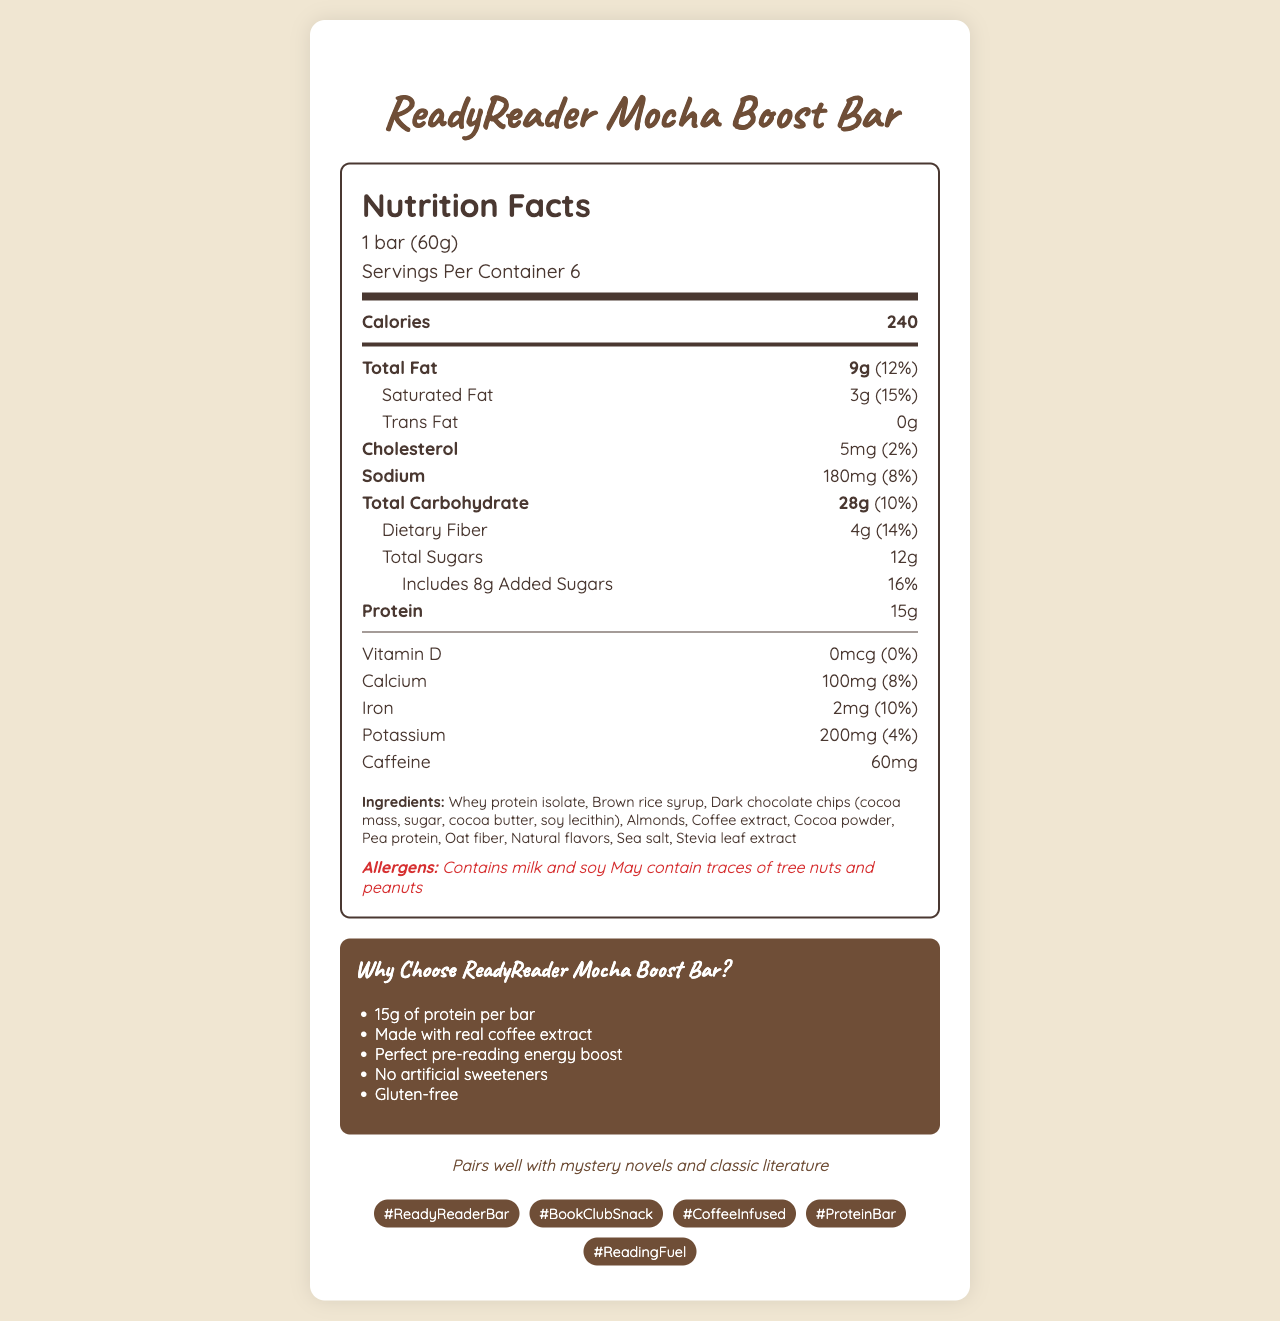what is the serving size of the ReadyReader Mocha Boost Bar? The serving size is explicitly mentioned in the nutrition label section of the document as "1 bar (60g)".
Answer: 1 bar (60g) How many servings are there per container? The document states that there are 6 servings per container.
Answer: 6 How much protein is in one bar? According to the nutrition facts, each bar contains 15 grams of protein.
Answer: 15g What percentage of the daily value of saturated fat does one bar provide? The document lists the daily value percentage for saturated fat as 15%.
Answer: 15% How many grams of dietary fiber are in one bar? The nutrition facts show that there are 4 grams of dietary fiber in one bar.
Answer: 4g Which ingredient lists "soy lecithin" as a component? The listed ingredients show dark chocolate chips containing cocoa mass, sugar, cocoa butter, and soy lecithin.
Answer: Dark chocolate chips Which vitamin or mineral has the highest daily value percentage? A. Calcium B. Iron C. Potassium Iron has a daily value percentage of 10%, which is higher compared to calcium (8%) and potassium (4%).
Answer: B. Iron What is the amount of added sugars in one bar? A. 4g B. 6g C. 8g D. 10g The nutrition facts show that the bar includes 8 grams of added sugars.
Answer: C. 8g Is the ReadyReader Mocha Boost Bar gluten-free? The marketing claims section explicitly states that the bar is gluten-free.
Answer: Yes Summarize the main idea of the document in one sentence. The document provides comprehensive details about the ReadyReader Mocha Boost Bar, including its nutritional content, ingredients, allergens, marketing claims, and how it pairs with book club activities.
Answer: The ReadyReader Mocha Boost Bar is a coffee-infused protein snack that provides an energy boost for reading, is made from real coffee extract, and includes detailed nutritional information and marketing claims. Which book genre does the ReadyReader Mocha Boost Bar pair well with? The document mentions that the bar pairs well with mystery novels and classic literature in the book club pairing section.
Answer: Mystery novels and classic literature Can this document determine if the ReadyReader Mocha Boost Bar is vegan-friendly? The document does not specify whether the bar is vegan, making it impossible to determine based solely on the provided information.
Answer: Not enough information 